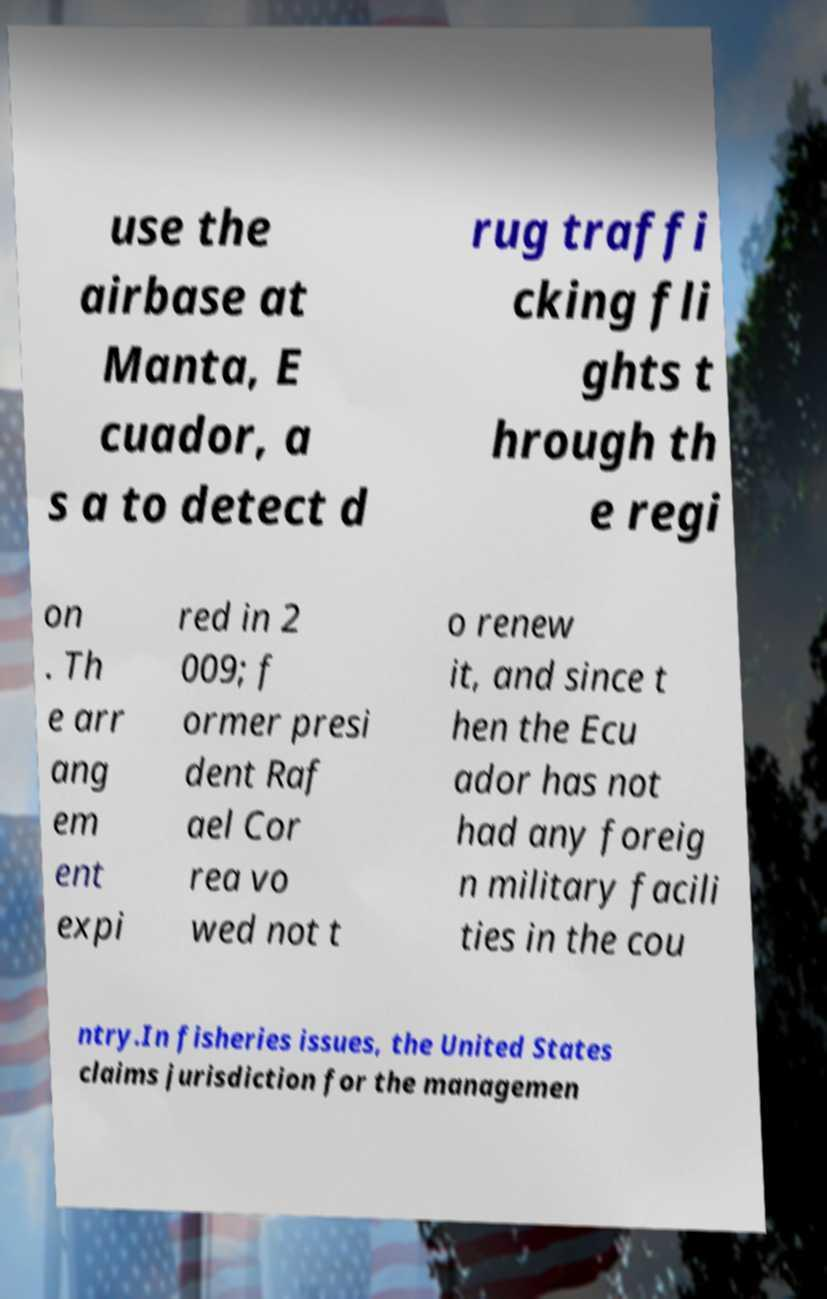For documentation purposes, I need the text within this image transcribed. Could you provide that? use the airbase at Manta, E cuador, a s a to detect d rug traffi cking fli ghts t hrough th e regi on . Th e arr ang em ent expi red in 2 009; f ormer presi dent Raf ael Cor rea vo wed not t o renew it, and since t hen the Ecu ador has not had any foreig n military facili ties in the cou ntry.In fisheries issues, the United States claims jurisdiction for the managemen 